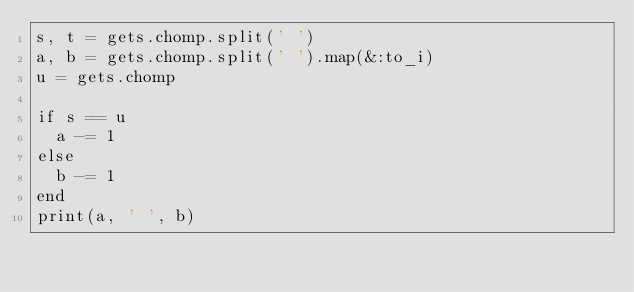Convert code to text. <code><loc_0><loc_0><loc_500><loc_500><_Ruby_>s, t = gets.chomp.split(' ')
a, b = gets.chomp.split(' ').map(&:to_i)
u = gets.chomp
 
if s == u
  a -= 1
else
  b -= 1
end
print(a, ' ', b)</code> 